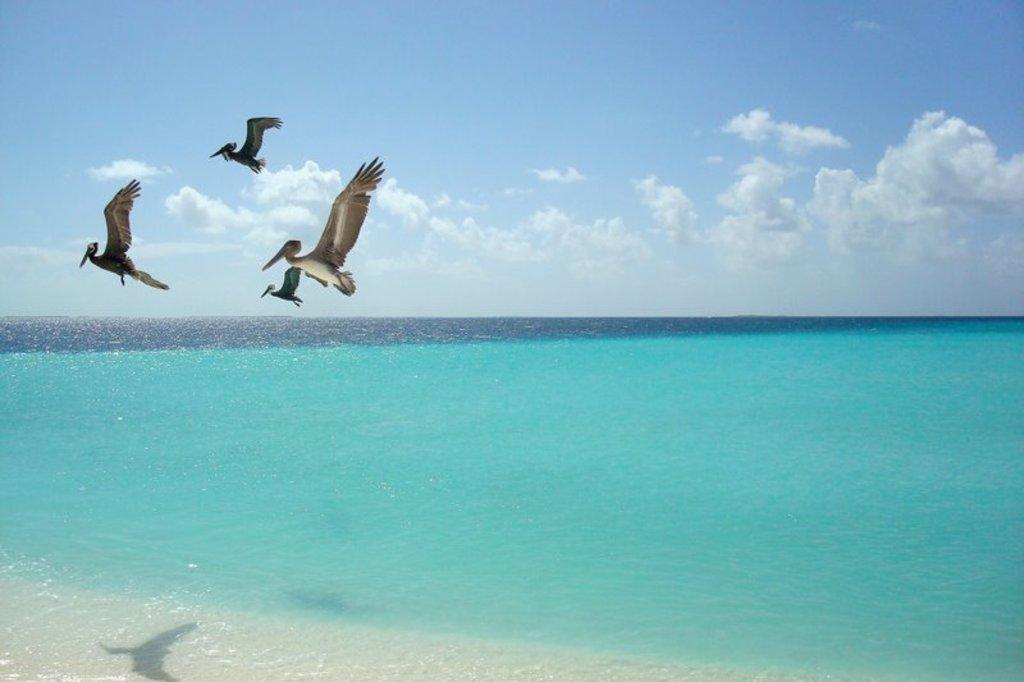How would you summarize this image in a sentence or two? As we can see in the image there is water, birds, sky and clouds. 